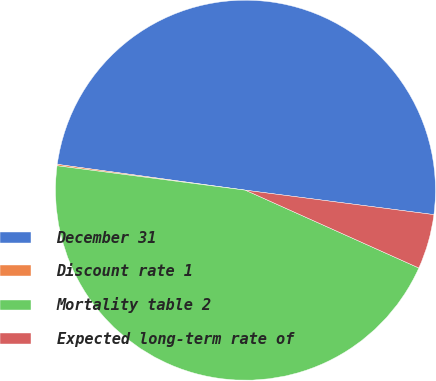<chart> <loc_0><loc_0><loc_500><loc_500><pie_chart><fcel>December 31<fcel>Discount rate 1<fcel>Mortality table 2<fcel>Expected long-term rate of<nl><fcel>49.88%<fcel>0.12%<fcel>45.34%<fcel>4.66%<nl></chart> 